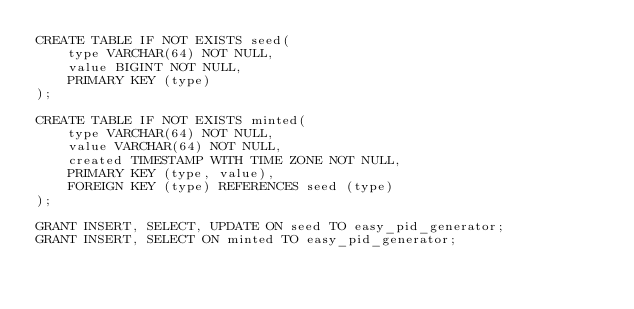Convert code to text. <code><loc_0><loc_0><loc_500><loc_500><_SQL_>CREATE TABLE IF NOT EXISTS seed(
    type VARCHAR(64) NOT NULL,
    value BIGINT NOT NULL,
    PRIMARY KEY (type)
);

CREATE TABLE IF NOT EXISTS minted(
    type VARCHAR(64) NOT NULL,
    value VARCHAR(64) NOT NULL,
    created TIMESTAMP WITH TIME ZONE NOT NULL,
    PRIMARY KEY (type, value),
    FOREIGN KEY (type) REFERENCES seed (type)
);

GRANT INSERT, SELECT, UPDATE ON seed TO easy_pid_generator;
GRANT INSERT, SELECT ON minted TO easy_pid_generator;
</code> 